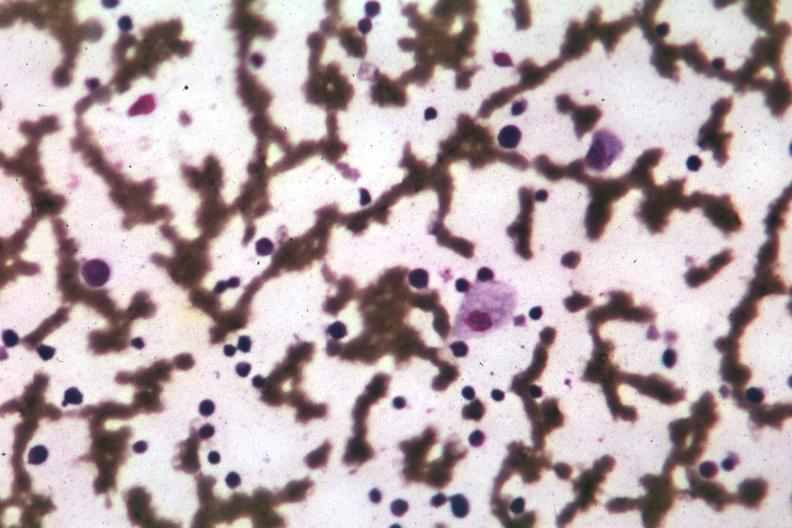does this image show wrights single cell easily seen?
Answer the question using a single word or phrase. Yes 